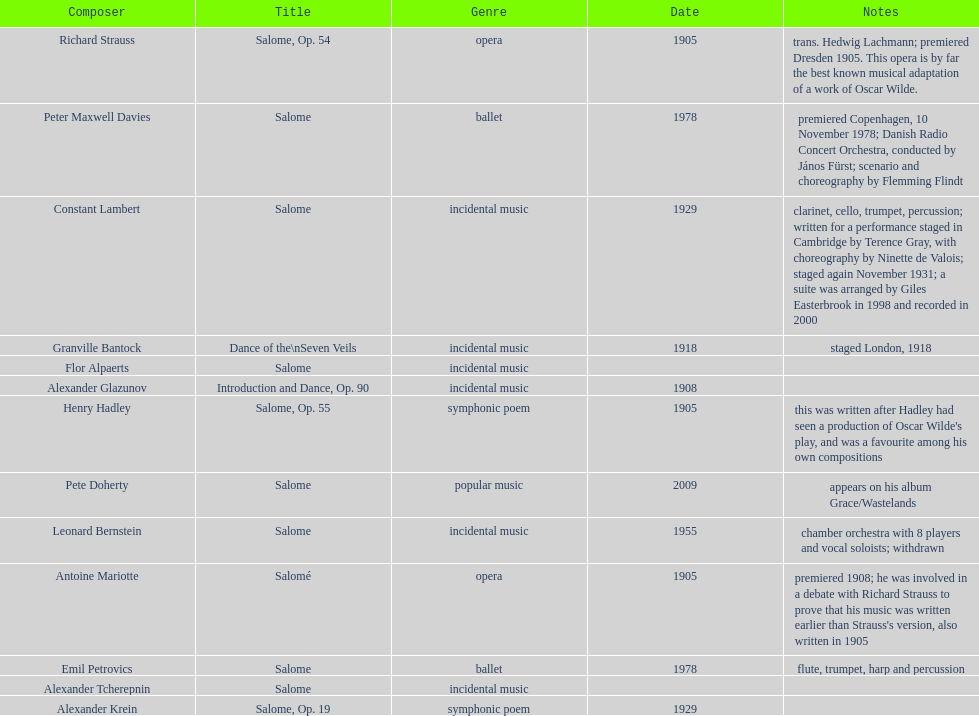Why type of genre was peter maxwell davies' work that was the same as emil petrovics' Ballet. 